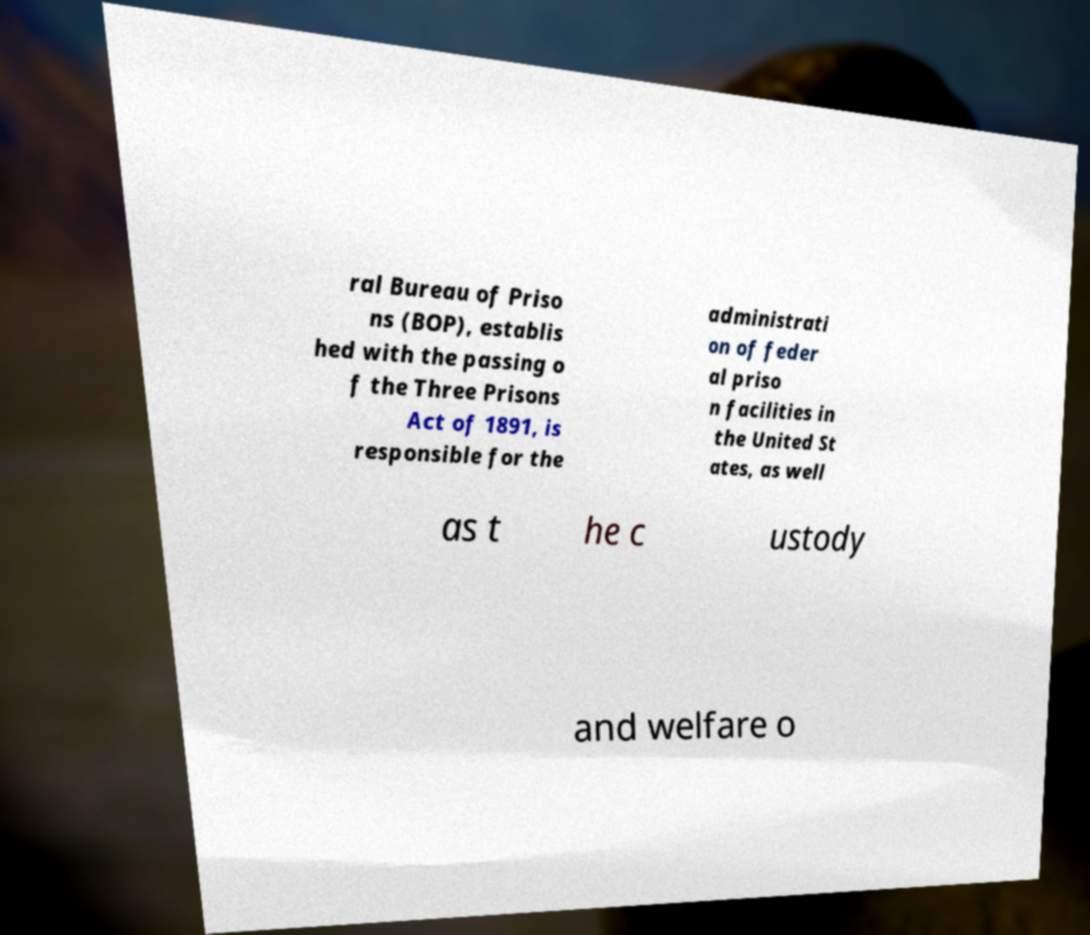Could you assist in decoding the text presented in this image and type it out clearly? ral Bureau of Priso ns (BOP), establis hed with the passing o f the Three Prisons Act of 1891, is responsible for the administrati on of feder al priso n facilities in the United St ates, as well as t he c ustody and welfare o 